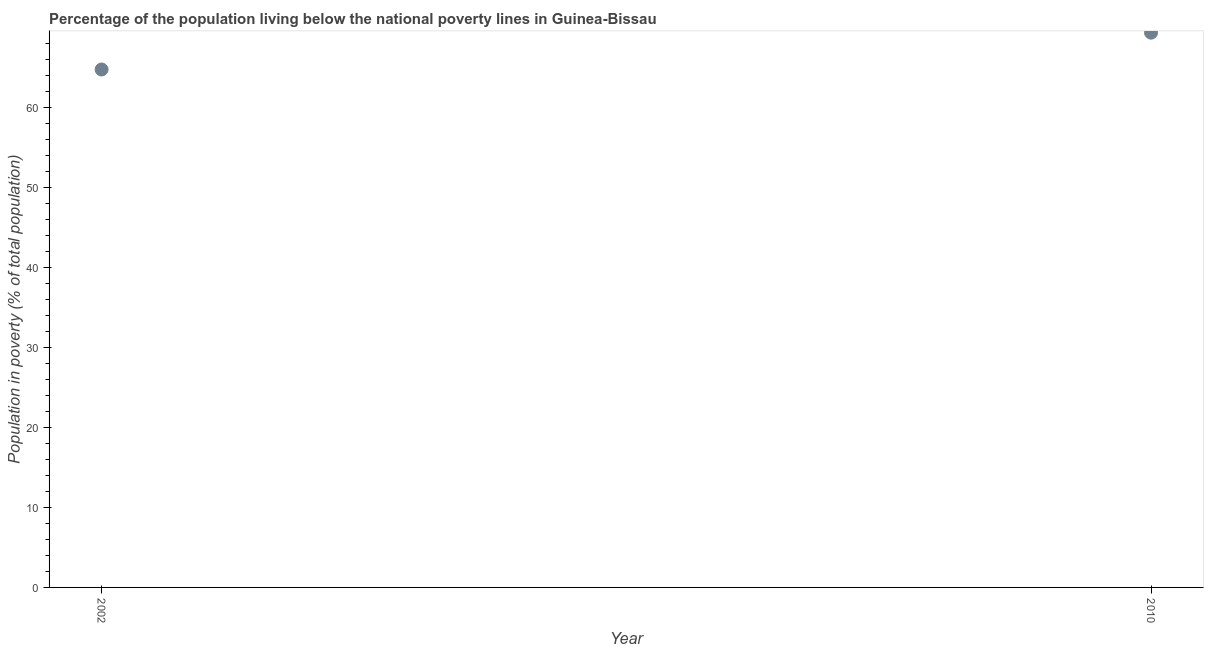What is the percentage of population living below poverty line in 2010?
Make the answer very short. 69.3. Across all years, what is the maximum percentage of population living below poverty line?
Provide a short and direct response. 69.3. Across all years, what is the minimum percentage of population living below poverty line?
Ensure brevity in your answer.  64.7. In which year was the percentage of population living below poverty line minimum?
Make the answer very short. 2002. What is the sum of the percentage of population living below poverty line?
Offer a terse response. 134. What is the difference between the percentage of population living below poverty line in 2002 and 2010?
Keep it short and to the point. -4.6. What is the median percentage of population living below poverty line?
Make the answer very short. 67. In how many years, is the percentage of population living below poverty line greater than 52 %?
Ensure brevity in your answer.  2. What is the ratio of the percentage of population living below poverty line in 2002 to that in 2010?
Make the answer very short. 0.93. Is the percentage of population living below poverty line in 2002 less than that in 2010?
Give a very brief answer. Yes. Does the percentage of population living below poverty line monotonically increase over the years?
Your response must be concise. Yes. How many dotlines are there?
Your answer should be very brief. 1. Are the values on the major ticks of Y-axis written in scientific E-notation?
Offer a very short reply. No. Does the graph contain grids?
Your answer should be compact. No. What is the title of the graph?
Offer a very short reply. Percentage of the population living below the national poverty lines in Guinea-Bissau. What is the label or title of the Y-axis?
Provide a short and direct response. Population in poverty (% of total population). What is the Population in poverty (% of total population) in 2002?
Give a very brief answer. 64.7. What is the Population in poverty (% of total population) in 2010?
Offer a very short reply. 69.3. What is the difference between the Population in poverty (% of total population) in 2002 and 2010?
Your answer should be compact. -4.6. What is the ratio of the Population in poverty (% of total population) in 2002 to that in 2010?
Offer a terse response. 0.93. 